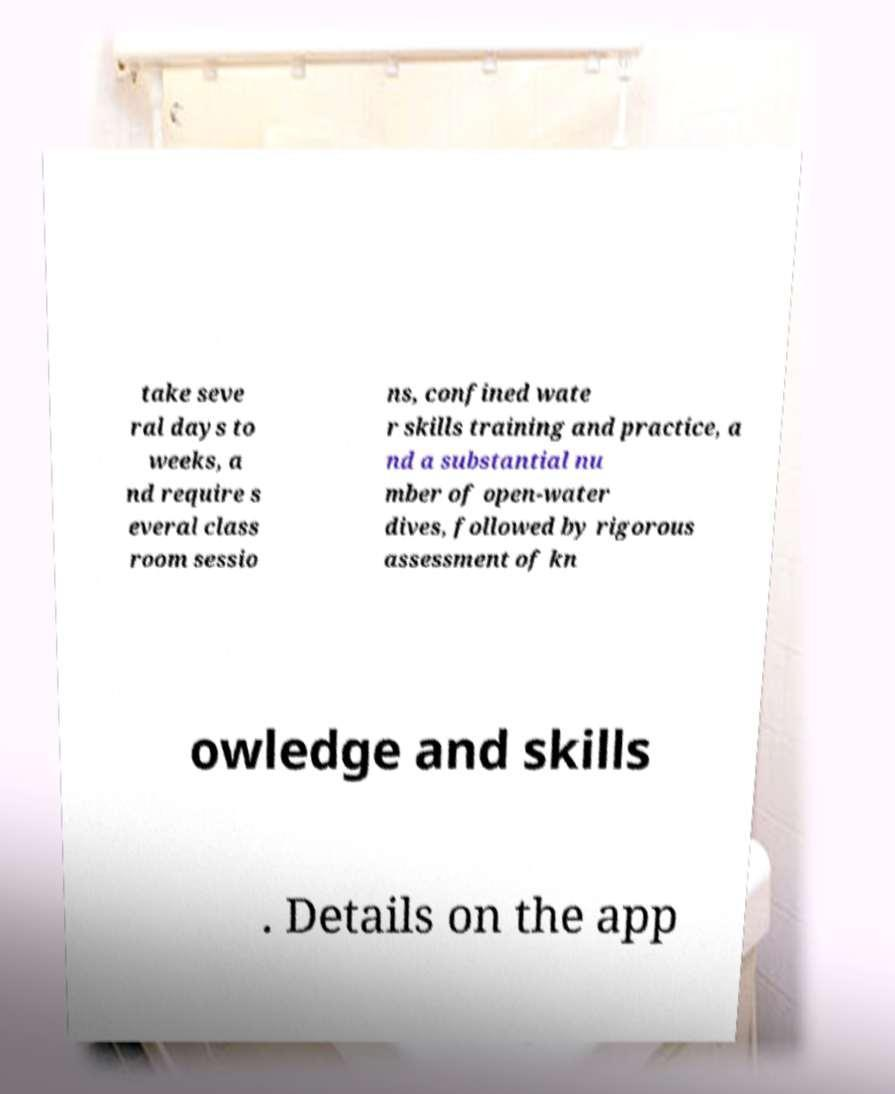Can you accurately transcribe the text from the provided image for me? take seve ral days to weeks, a nd require s everal class room sessio ns, confined wate r skills training and practice, a nd a substantial nu mber of open-water dives, followed by rigorous assessment of kn owledge and skills . Details on the app 